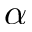<formula> <loc_0><loc_0><loc_500><loc_500>\alpha</formula> 